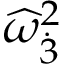<formula> <loc_0><loc_0><loc_500><loc_500>{ \widehat { \omega } } _ { \dot { 3 } } ^ { 2 }</formula> 